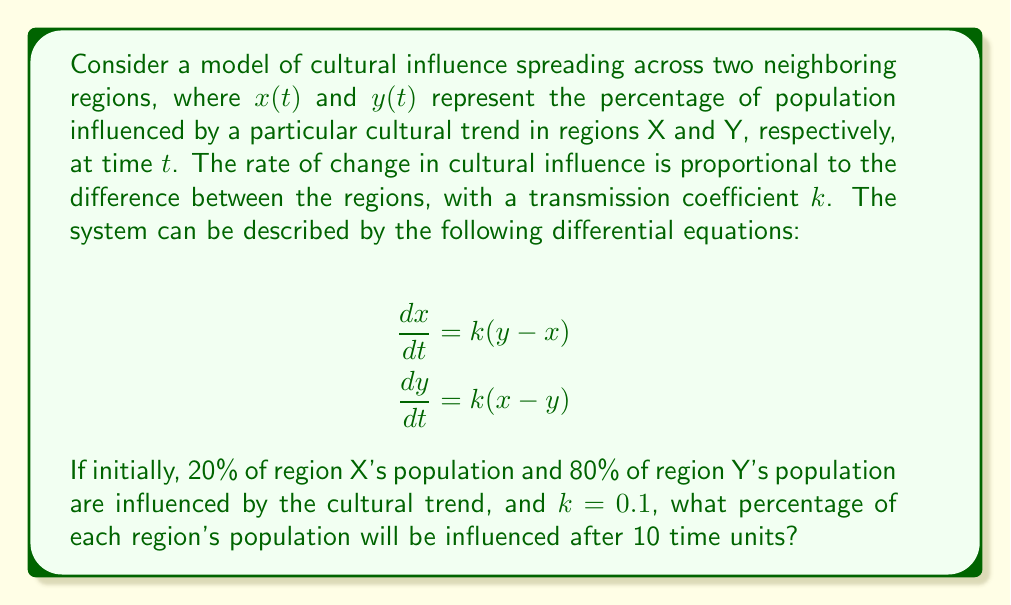Help me with this question. To solve this system of differential equations, we'll follow these steps:

1) First, we need to find the general solution for this system. The equations can be rewritten as:
   $$\frac{d}{dt}(x - y) = -2k(x - y)$$
   $$\frac{d}{dt}(x + y) = 0$$

2) From the second equation, we can conclude that $x + y = C_1$, where $C_1$ is a constant.
   From the first equation, we get: $x - y = C_2e^{-2kt}$, where $C_2$ is another constant.

3) Solving for x and y:
   $$x = \frac{1}{2}(C_1 + C_2e^{-2kt})$$
   $$y = \frac{1}{2}(C_1 - C_2e^{-2kt})$$

4) Using the initial conditions: $x(0) = 0.2$ and $y(0) = 0.8$, we can find $C_1$ and $C_2$:
   $$C_1 = x(0) + y(0) = 0.2 + 0.8 = 1$$
   $$C_2 = x(0) - y(0) = 0.2 - 0.8 = -0.6$$

5) Therefore, the solutions are:
   $$x(t) = \frac{1}{2}(1 - 0.6e^{-2kt})$$
   $$y(t) = \frac{1}{2}(1 + 0.6e^{-2kt})$$

6) Given $k = 0.1$ and $t = 10$, we can calculate:
   $$x(10) = \frac{1}{2}(1 - 0.6e^{-2(0.1)(10)}) \approx 0.4693$$
   $$y(10) = \frac{1}{2}(1 + 0.6e^{-2(0.1)(10)}) \approx 0.5307$$

7) Converting to percentages:
   Region X: $0.4693 \times 100\% \approx 46.93\%$
   Region Y: $0.5307 \times 100\% \approx 53.07\%$
Answer: Region X: 46.93%, Region Y: 53.07% 